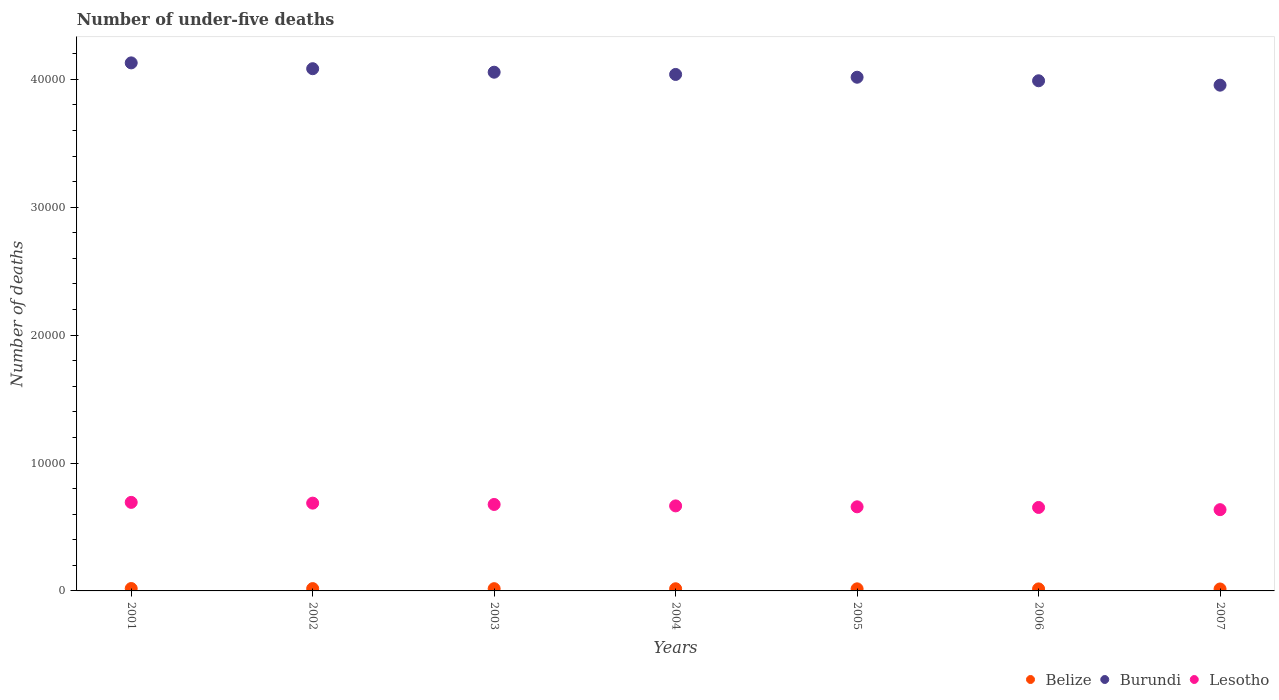How many different coloured dotlines are there?
Give a very brief answer. 3. What is the number of under-five deaths in Belize in 2005?
Provide a succinct answer. 163. Across all years, what is the maximum number of under-five deaths in Burundi?
Provide a short and direct response. 4.13e+04. Across all years, what is the minimum number of under-five deaths in Lesotho?
Make the answer very short. 6352. In which year was the number of under-five deaths in Lesotho maximum?
Your answer should be very brief. 2001. What is the total number of under-five deaths in Lesotho in the graph?
Offer a terse response. 4.66e+04. What is the difference between the number of under-five deaths in Belize in 2004 and that in 2007?
Provide a succinct answer. 17. What is the difference between the number of under-five deaths in Belize in 2002 and the number of under-five deaths in Lesotho in 2007?
Offer a terse response. -6171. What is the average number of under-five deaths in Lesotho per year?
Your answer should be very brief. 6663.29. In the year 2001, what is the difference between the number of under-five deaths in Lesotho and number of under-five deaths in Burundi?
Offer a very short reply. -3.44e+04. In how many years, is the number of under-five deaths in Lesotho greater than 12000?
Offer a terse response. 0. What is the ratio of the number of under-five deaths in Burundi in 2002 to that in 2006?
Provide a succinct answer. 1.02. Is the number of under-five deaths in Belize in 2004 less than that in 2006?
Keep it short and to the point. No. Is the difference between the number of under-five deaths in Lesotho in 2004 and 2007 greater than the difference between the number of under-five deaths in Burundi in 2004 and 2007?
Keep it short and to the point. No. What is the difference between the highest and the second highest number of under-five deaths in Lesotho?
Provide a succinct answer. 59. What is the difference between the highest and the lowest number of under-five deaths in Lesotho?
Your answer should be very brief. 570. In how many years, is the number of under-five deaths in Belize greater than the average number of under-five deaths in Belize taken over all years?
Your response must be concise. 3. Is it the case that in every year, the sum of the number of under-five deaths in Belize and number of under-five deaths in Burundi  is greater than the number of under-five deaths in Lesotho?
Offer a very short reply. Yes. Is the number of under-five deaths in Lesotho strictly greater than the number of under-five deaths in Belize over the years?
Make the answer very short. Yes. Is the number of under-five deaths in Lesotho strictly less than the number of under-five deaths in Belize over the years?
Provide a short and direct response. No. How many dotlines are there?
Offer a very short reply. 3. How many years are there in the graph?
Your answer should be very brief. 7. What is the difference between two consecutive major ticks on the Y-axis?
Offer a very short reply. 10000. Does the graph contain any zero values?
Your response must be concise. No. Where does the legend appear in the graph?
Your response must be concise. Bottom right. How many legend labels are there?
Your answer should be very brief. 3. What is the title of the graph?
Provide a short and direct response. Number of under-five deaths. Does "Curacao" appear as one of the legend labels in the graph?
Your answer should be very brief. No. What is the label or title of the Y-axis?
Offer a very short reply. Number of deaths. What is the Number of deaths of Belize in 2001?
Make the answer very short. 187. What is the Number of deaths in Burundi in 2001?
Your answer should be compact. 4.13e+04. What is the Number of deaths of Lesotho in 2001?
Offer a terse response. 6922. What is the Number of deaths in Belize in 2002?
Offer a terse response. 181. What is the Number of deaths of Burundi in 2002?
Offer a terse response. 4.08e+04. What is the Number of deaths in Lesotho in 2002?
Give a very brief answer. 6863. What is the Number of deaths of Belize in 2003?
Make the answer very short. 175. What is the Number of deaths in Burundi in 2003?
Your answer should be very brief. 4.06e+04. What is the Number of deaths in Lesotho in 2003?
Give a very brief answer. 6759. What is the Number of deaths in Belize in 2004?
Offer a terse response. 169. What is the Number of deaths in Burundi in 2004?
Your response must be concise. 4.04e+04. What is the Number of deaths of Lesotho in 2004?
Provide a succinct answer. 6647. What is the Number of deaths in Belize in 2005?
Make the answer very short. 163. What is the Number of deaths in Burundi in 2005?
Your answer should be very brief. 4.02e+04. What is the Number of deaths of Lesotho in 2005?
Make the answer very short. 6575. What is the Number of deaths in Belize in 2006?
Offer a very short reply. 158. What is the Number of deaths of Burundi in 2006?
Offer a very short reply. 3.99e+04. What is the Number of deaths in Lesotho in 2006?
Offer a very short reply. 6525. What is the Number of deaths in Belize in 2007?
Provide a short and direct response. 152. What is the Number of deaths in Burundi in 2007?
Ensure brevity in your answer.  3.95e+04. What is the Number of deaths in Lesotho in 2007?
Provide a succinct answer. 6352. Across all years, what is the maximum Number of deaths in Belize?
Your response must be concise. 187. Across all years, what is the maximum Number of deaths in Burundi?
Offer a terse response. 4.13e+04. Across all years, what is the maximum Number of deaths in Lesotho?
Ensure brevity in your answer.  6922. Across all years, what is the minimum Number of deaths in Belize?
Offer a terse response. 152. Across all years, what is the minimum Number of deaths in Burundi?
Your answer should be very brief. 3.95e+04. Across all years, what is the minimum Number of deaths in Lesotho?
Provide a succinct answer. 6352. What is the total Number of deaths of Belize in the graph?
Provide a short and direct response. 1185. What is the total Number of deaths in Burundi in the graph?
Make the answer very short. 2.83e+05. What is the total Number of deaths in Lesotho in the graph?
Your answer should be very brief. 4.66e+04. What is the difference between the Number of deaths of Burundi in 2001 and that in 2002?
Offer a terse response. 455. What is the difference between the Number of deaths of Lesotho in 2001 and that in 2002?
Make the answer very short. 59. What is the difference between the Number of deaths in Belize in 2001 and that in 2003?
Keep it short and to the point. 12. What is the difference between the Number of deaths of Burundi in 2001 and that in 2003?
Your answer should be very brief. 729. What is the difference between the Number of deaths in Lesotho in 2001 and that in 2003?
Give a very brief answer. 163. What is the difference between the Number of deaths of Belize in 2001 and that in 2004?
Offer a terse response. 18. What is the difference between the Number of deaths in Burundi in 2001 and that in 2004?
Provide a succinct answer. 904. What is the difference between the Number of deaths in Lesotho in 2001 and that in 2004?
Ensure brevity in your answer.  275. What is the difference between the Number of deaths in Burundi in 2001 and that in 2005?
Your response must be concise. 1122. What is the difference between the Number of deaths of Lesotho in 2001 and that in 2005?
Offer a very short reply. 347. What is the difference between the Number of deaths of Burundi in 2001 and that in 2006?
Keep it short and to the point. 1399. What is the difference between the Number of deaths in Lesotho in 2001 and that in 2006?
Make the answer very short. 397. What is the difference between the Number of deaths in Burundi in 2001 and that in 2007?
Your answer should be compact. 1742. What is the difference between the Number of deaths in Lesotho in 2001 and that in 2007?
Provide a succinct answer. 570. What is the difference between the Number of deaths of Belize in 2002 and that in 2003?
Offer a terse response. 6. What is the difference between the Number of deaths of Burundi in 2002 and that in 2003?
Provide a short and direct response. 274. What is the difference between the Number of deaths in Lesotho in 2002 and that in 2003?
Provide a succinct answer. 104. What is the difference between the Number of deaths in Burundi in 2002 and that in 2004?
Offer a very short reply. 449. What is the difference between the Number of deaths in Lesotho in 2002 and that in 2004?
Your response must be concise. 216. What is the difference between the Number of deaths in Belize in 2002 and that in 2005?
Keep it short and to the point. 18. What is the difference between the Number of deaths in Burundi in 2002 and that in 2005?
Your response must be concise. 667. What is the difference between the Number of deaths of Lesotho in 2002 and that in 2005?
Offer a very short reply. 288. What is the difference between the Number of deaths of Belize in 2002 and that in 2006?
Keep it short and to the point. 23. What is the difference between the Number of deaths in Burundi in 2002 and that in 2006?
Your answer should be very brief. 944. What is the difference between the Number of deaths of Lesotho in 2002 and that in 2006?
Provide a succinct answer. 338. What is the difference between the Number of deaths of Belize in 2002 and that in 2007?
Your response must be concise. 29. What is the difference between the Number of deaths in Burundi in 2002 and that in 2007?
Ensure brevity in your answer.  1287. What is the difference between the Number of deaths in Lesotho in 2002 and that in 2007?
Give a very brief answer. 511. What is the difference between the Number of deaths in Burundi in 2003 and that in 2004?
Your answer should be very brief. 175. What is the difference between the Number of deaths of Lesotho in 2003 and that in 2004?
Provide a succinct answer. 112. What is the difference between the Number of deaths in Belize in 2003 and that in 2005?
Your answer should be compact. 12. What is the difference between the Number of deaths in Burundi in 2003 and that in 2005?
Provide a succinct answer. 393. What is the difference between the Number of deaths in Lesotho in 2003 and that in 2005?
Your response must be concise. 184. What is the difference between the Number of deaths of Belize in 2003 and that in 2006?
Offer a terse response. 17. What is the difference between the Number of deaths of Burundi in 2003 and that in 2006?
Offer a terse response. 670. What is the difference between the Number of deaths in Lesotho in 2003 and that in 2006?
Give a very brief answer. 234. What is the difference between the Number of deaths in Burundi in 2003 and that in 2007?
Your response must be concise. 1013. What is the difference between the Number of deaths in Lesotho in 2003 and that in 2007?
Keep it short and to the point. 407. What is the difference between the Number of deaths of Belize in 2004 and that in 2005?
Offer a terse response. 6. What is the difference between the Number of deaths of Burundi in 2004 and that in 2005?
Provide a short and direct response. 218. What is the difference between the Number of deaths of Burundi in 2004 and that in 2006?
Your answer should be very brief. 495. What is the difference between the Number of deaths in Lesotho in 2004 and that in 2006?
Offer a terse response. 122. What is the difference between the Number of deaths of Belize in 2004 and that in 2007?
Keep it short and to the point. 17. What is the difference between the Number of deaths in Burundi in 2004 and that in 2007?
Offer a terse response. 838. What is the difference between the Number of deaths of Lesotho in 2004 and that in 2007?
Give a very brief answer. 295. What is the difference between the Number of deaths of Burundi in 2005 and that in 2006?
Make the answer very short. 277. What is the difference between the Number of deaths in Belize in 2005 and that in 2007?
Provide a succinct answer. 11. What is the difference between the Number of deaths of Burundi in 2005 and that in 2007?
Your answer should be compact. 620. What is the difference between the Number of deaths of Lesotho in 2005 and that in 2007?
Your response must be concise. 223. What is the difference between the Number of deaths of Burundi in 2006 and that in 2007?
Your answer should be compact. 343. What is the difference between the Number of deaths of Lesotho in 2006 and that in 2007?
Keep it short and to the point. 173. What is the difference between the Number of deaths of Belize in 2001 and the Number of deaths of Burundi in 2002?
Your response must be concise. -4.06e+04. What is the difference between the Number of deaths in Belize in 2001 and the Number of deaths in Lesotho in 2002?
Ensure brevity in your answer.  -6676. What is the difference between the Number of deaths of Burundi in 2001 and the Number of deaths of Lesotho in 2002?
Ensure brevity in your answer.  3.44e+04. What is the difference between the Number of deaths of Belize in 2001 and the Number of deaths of Burundi in 2003?
Offer a very short reply. -4.04e+04. What is the difference between the Number of deaths of Belize in 2001 and the Number of deaths of Lesotho in 2003?
Give a very brief answer. -6572. What is the difference between the Number of deaths of Burundi in 2001 and the Number of deaths of Lesotho in 2003?
Your response must be concise. 3.45e+04. What is the difference between the Number of deaths in Belize in 2001 and the Number of deaths in Burundi in 2004?
Provide a succinct answer. -4.02e+04. What is the difference between the Number of deaths in Belize in 2001 and the Number of deaths in Lesotho in 2004?
Offer a terse response. -6460. What is the difference between the Number of deaths in Burundi in 2001 and the Number of deaths in Lesotho in 2004?
Provide a succinct answer. 3.46e+04. What is the difference between the Number of deaths in Belize in 2001 and the Number of deaths in Burundi in 2005?
Your response must be concise. -4.00e+04. What is the difference between the Number of deaths in Belize in 2001 and the Number of deaths in Lesotho in 2005?
Provide a succinct answer. -6388. What is the difference between the Number of deaths in Burundi in 2001 and the Number of deaths in Lesotho in 2005?
Offer a terse response. 3.47e+04. What is the difference between the Number of deaths of Belize in 2001 and the Number of deaths of Burundi in 2006?
Keep it short and to the point. -3.97e+04. What is the difference between the Number of deaths of Belize in 2001 and the Number of deaths of Lesotho in 2006?
Your answer should be compact. -6338. What is the difference between the Number of deaths of Burundi in 2001 and the Number of deaths of Lesotho in 2006?
Make the answer very short. 3.48e+04. What is the difference between the Number of deaths of Belize in 2001 and the Number of deaths of Burundi in 2007?
Keep it short and to the point. -3.94e+04. What is the difference between the Number of deaths of Belize in 2001 and the Number of deaths of Lesotho in 2007?
Ensure brevity in your answer.  -6165. What is the difference between the Number of deaths of Burundi in 2001 and the Number of deaths of Lesotho in 2007?
Keep it short and to the point. 3.49e+04. What is the difference between the Number of deaths in Belize in 2002 and the Number of deaths in Burundi in 2003?
Your answer should be compact. -4.04e+04. What is the difference between the Number of deaths in Belize in 2002 and the Number of deaths in Lesotho in 2003?
Ensure brevity in your answer.  -6578. What is the difference between the Number of deaths of Burundi in 2002 and the Number of deaths of Lesotho in 2003?
Your answer should be compact. 3.41e+04. What is the difference between the Number of deaths of Belize in 2002 and the Number of deaths of Burundi in 2004?
Provide a succinct answer. -4.02e+04. What is the difference between the Number of deaths in Belize in 2002 and the Number of deaths in Lesotho in 2004?
Your response must be concise. -6466. What is the difference between the Number of deaths in Burundi in 2002 and the Number of deaths in Lesotho in 2004?
Keep it short and to the point. 3.42e+04. What is the difference between the Number of deaths in Belize in 2002 and the Number of deaths in Burundi in 2005?
Your answer should be very brief. -4.00e+04. What is the difference between the Number of deaths of Belize in 2002 and the Number of deaths of Lesotho in 2005?
Keep it short and to the point. -6394. What is the difference between the Number of deaths in Burundi in 2002 and the Number of deaths in Lesotho in 2005?
Your answer should be compact. 3.42e+04. What is the difference between the Number of deaths in Belize in 2002 and the Number of deaths in Burundi in 2006?
Offer a very short reply. -3.97e+04. What is the difference between the Number of deaths in Belize in 2002 and the Number of deaths in Lesotho in 2006?
Your response must be concise. -6344. What is the difference between the Number of deaths of Burundi in 2002 and the Number of deaths of Lesotho in 2006?
Keep it short and to the point. 3.43e+04. What is the difference between the Number of deaths of Belize in 2002 and the Number of deaths of Burundi in 2007?
Make the answer very short. -3.94e+04. What is the difference between the Number of deaths of Belize in 2002 and the Number of deaths of Lesotho in 2007?
Keep it short and to the point. -6171. What is the difference between the Number of deaths in Burundi in 2002 and the Number of deaths in Lesotho in 2007?
Keep it short and to the point. 3.45e+04. What is the difference between the Number of deaths in Belize in 2003 and the Number of deaths in Burundi in 2004?
Offer a very short reply. -4.02e+04. What is the difference between the Number of deaths of Belize in 2003 and the Number of deaths of Lesotho in 2004?
Provide a succinct answer. -6472. What is the difference between the Number of deaths in Burundi in 2003 and the Number of deaths in Lesotho in 2004?
Offer a very short reply. 3.39e+04. What is the difference between the Number of deaths in Belize in 2003 and the Number of deaths in Burundi in 2005?
Keep it short and to the point. -4.00e+04. What is the difference between the Number of deaths in Belize in 2003 and the Number of deaths in Lesotho in 2005?
Your response must be concise. -6400. What is the difference between the Number of deaths of Burundi in 2003 and the Number of deaths of Lesotho in 2005?
Your response must be concise. 3.40e+04. What is the difference between the Number of deaths of Belize in 2003 and the Number of deaths of Burundi in 2006?
Your response must be concise. -3.97e+04. What is the difference between the Number of deaths of Belize in 2003 and the Number of deaths of Lesotho in 2006?
Offer a very short reply. -6350. What is the difference between the Number of deaths of Burundi in 2003 and the Number of deaths of Lesotho in 2006?
Provide a short and direct response. 3.40e+04. What is the difference between the Number of deaths in Belize in 2003 and the Number of deaths in Burundi in 2007?
Give a very brief answer. -3.94e+04. What is the difference between the Number of deaths in Belize in 2003 and the Number of deaths in Lesotho in 2007?
Your answer should be compact. -6177. What is the difference between the Number of deaths of Burundi in 2003 and the Number of deaths of Lesotho in 2007?
Make the answer very short. 3.42e+04. What is the difference between the Number of deaths of Belize in 2004 and the Number of deaths of Burundi in 2005?
Provide a short and direct response. -4.00e+04. What is the difference between the Number of deaths of Belize in 2004 and the Number of deaths of Lesotho in 2005?
Provide a short and direct response. -6406. What is the difference between the Number of deaths of Burundi in 2004 and the Number of deaths of Lesotho in 2005?
Your response must be concise. 3.38e+04. What is the difference between the Number of deaths of Belize in 2004 and the Number of deaths of Burundi in 2006?
Your response must be concise. -3.97e+04. What is the difference between the Number of deaths of Belize in 2004 and the Number of deaths of Lesotho in 2006?
Offer a terse response. -6356. What is the difference between the Number of deaths in Burundi in 2004 and the Number of deaths in Lesotho in 2006?
Offer a very short reply. 3.39e+04. What is the difference between the Number of deaths of Belize in 2004 and the Number of deaths of Burundi in 2007?
Give a very brief answer. -3.94e+04. What is the difference between the Number of deaths in Belize in 2004 and the Number of deaths in Lesotho in 2007?
Your answer should be very brief. -6183. What is the difference between the Number of deaths of Burundi in 2004 and the Number of deaths of Lesotho in 2007?
Ensure brevity in your answer.  3.40e+04. What is the difference between the Number of deaths in Belize in 2005 and the Number of deaths in Burundi in 2006?
Provide a succinct answer. -3.97e+04. What is the difference between the Number of deaths in Belize in 2005 and the Number of deaths in Lesotho in 2006?
Provide a short and direct response. -6362. What is the difference between the Number of deaths of Burundi in 2005 and the Number of deaths of Lesotho in 2006?
Make the answer very short. 3.36e+04. What is the difference between the Number of deaths of Belize in 2005 and the Number of deaths of Burundi in 2007?
Offer a very short reply. -3.94e+04. What is the difference between the Number of deaths of Belize in 2005 and the Number of deaths of Lesotho in 2007?
Your answer should be compact. -6189. What is the difference between the Number of deaths in Burundi in 2005 and the Number of deaths in Lesotho in 2007?
Provide a succinct answer. 3.38e+04. What is the difference between the Number of deaths in Belize in 2006 and the Number of deaths in Burundi in 2007?
Provide a succinct answer. -3.94e+04. What is the difference between the Number of deaths in Belize in 2006 and the Number of deaths in Lesotho in 2007?
Keep it short and to the point. -6194. What is the difference between the Number of deaths of Burundi in 2006 and the Number of deaths of Lesotho in 2007?
Your response must be concise. 3.35e+04. What is the average Number of deaths in Belize per year?
Offer a very short reply. 169.29. What is the average Number of deaths in Burundi per year?
Your response must be concise. 4.04e+04. What is the average Number of deaths of Lesotho per year?
Give a very brief answer. 6663.29. In the year 2001, what is the difference between the Number of deaths of Belize and Number of deaths of Burundi?
Your answer should be compact. -4.11e+04. In the year 2001, what is the difference between the Number of deaths in Belize and Number of deaths in Lesotho?
Keep it short and to the point. -6735. In the year 2001, what is the difference between the Number of deaths in Burundi and Number of deaths in Lesotho?
Offer a very short reply. 3.44e+04. In the year 2002, what is the difference between the Number of deaths in Belize and Number of deaths in Burundi?
Provide a succinct answer. -4.06e+04. In the year 2002, what is the difference between the Number of deaths in Belize and Number of deaths in Lesotho?
Give a very brief answer. -6682. In the year 2002, what is the difference between the Number of deaths in Burundi and Number of deaths in Lesotho?
Your response must be concise. 3.40e+04. In the year 2003, what is the difference between the Number of deaths of Belize and Number of deaths of Burundi?
Give a very brief answer. -4.04e+04. In the year 2003, what is the difference between the Number of deaths in Belize and Number of deaths in Lesotho?
Provide a succinct answer. -6584. In the year 2003, what is the difference between the Number of deaths of Burundi and Number of deaths of Lesotho?
Make the answer very short. 3.38e+04. In the year 2004, what is the difference between the Number of deaths of Belize and Number of deaths of Burundi?
Your answer should be very brief. -4.02e+04. In the year 2004, what is the difference between the Number of deaths in Belize and Number of deaths in Lesotho?
Your answer should be very brief. -6478. In the year 2004, what is the difference between the Number of deaths of Burundi and Number of deaths of Lesotho?
Your answer should be very brief. 3.37e+04. In the year 2005, what is the difference between the Number of deaths in Belize and Number of deaths in Burundi?
Your response must be concise. -4.00e+04. In the year 2005, what is the difference between the Number of deaths of Belize and Number of deaths of Lesotho?
Make the answer very short. -6412. In the year 2005, what is the difference between the Number of deaths of Burundi and Number of deaths of Lesotho?
Provide a short and direct response. 3.36e+04. In the year 2006, what is the difference between the Number of deaths in Belize and Number of deaths in Burundi?
Ensure brevity in your answer.  -3.97e+04. In the year 2006, what is the difference between the Number of deaths of Belize and Number of deaths of Lesotho?
Your response must be concise. -6367. In the year 2006, what is the difference between the Number of deaths in Burundi and Number of deaths in Lesotho?
Your answer should be very brief. 3.34e+04. In the year 2007, what is the difference between the Number of deaths in Belize and Number of deaths in Burundi?
Keep it short and to the point. -3.94e+04. In the year 2007, what is the difference between the Number of deaths in Belize and Number of deaths in Lesotho?
Your answer should be compact. -6200. In the year 2007, what is the difference between the Number of deaths in Burundi and Number of deaths in Lesotho?
Give a very brief answer. 3.32e+04. What is the ratio of the Number of deaths of Belize in 2001 to that in 2002?
Your response must be concise. 1.03. What is the ratio of the Number of deaths in Burundi in 2001 to that in 2002?
Your answer should be very brief. 1.01. What is the ratio of the Number of deaths in Lesotho in 2001 to that in 2002?
Provide a succinct answer. 1.01. What is the ratio of the Number of deaths of Belize in 2001 to that in 2003?
Provide a short and direct response. 1.07. What is the ratio of the Number of deaths in Lesotho in 2001 to that in 2003?
Provide a short and direct response. 1.02. What is the ratio of the Number of deaths of Belize in 2001 to that in 2004?
Your answer should be compact. 1.11. What is the ratio of the Number of deaths of Burundi in 2001 to that in 2004?
Offer a very short reply. 1.02. What is the ratio of the Number of deaths in Lesotho in 2001 to that in 2004?
Your answer should be compact. 1.04. What is the ratio of the Number of deaths in Belize in 2001 to that in 2005?
Your answer should be compact. 1.15. What is the ratio of the Number of deaths in Burundi in 2001 to that in 2005?
Your answer should be very brief. 1.03. What is the ratio of the Number of deaths in Lesotho in 2001 to that in 2005?
Your response must be concise. 1.05. What is the ratio of the Number of deaths in Belize in 2001 to that in 2006?
Offer a very short reply. 1.18. What is the ratio of the Number of deaths of Burundi in 2001 to that in 2006?
Ensure brevity in your answer.  1.04. What is the ratio of the Number of deaths in Lesotho in 2001 to that in 2006?
Offer a very short reply. 1.06. What is the ratio of the Number of deaths in Belize in 2001 to that in 2007?
Provide a succinct answer. 1.23. What is the ratio of the Number of deaths in Burundi in 2001 to that in 2007?
Give a very brief answer. 1.04. What is the ratio of the Number of deaths in Lesotho in 2001 to that in 2007?
Offer a terse response. 1.09. What is the ratio of the Number of deaths of Belize in 2002 to that in 2003?
Offer a terse response. 1.03. What is the ratio of the Number of deaths in Burundi in 2002 to that in 2003?
Your answer should be very brief. 1.01. What is the ratio of the Number of deaths of Lesotho in 2002 to that in 2003?
Provide a succinct answer. 1.02. What is the ratio of the Number of deaths in Belize in 2002 to that in 2004?
Offer a terse response. 1.07. What is the ratio of the Number of deaths of Burundi in 2002 to that in 2004?
Give a very brief answer. 1.01. What is the ratio of the Number of deaths in Lesotho in 2002 to that in 2004?
Your response must be concise. 1.03. What is the ratio of the Number of deaths in Belize in 2002 to that in 2005?
Ensure brevity in your answer.  1.11. What is the ratio of the Number of deaths in Burundi in 2002 to that in 2005?
Provide a short and direct response. 1.02. What is the ratio of the Number of deaths in Lesotho in 2002 to that in 2005?
Your answer should be very brief. 1.04. What is the ratio of the Number of deaths in Belize in 2002 to that in 2006?
Your answer should be compact. 1.15. What is the ratio of the Number of deaths in Burundi in 2002 to that in 2006?
Ensure brevity in your answer.  1.02. What is the ratio of the Number of deaths of Lesotho in 2002 to that in 2006?
Make the answer very short. 1.05. What is the ratio of the Number of deaths in Belize in 2002 to that in 2007?
Make the answer very short. 1.19. What is the ratio of the Number of deaths in Burundi in 2002 to that in 2007?
Make the answer very short. 1.03. What is the ratio of the Number of deaths in Lesotho in 2002 to that in 2007?
Give a very brief answer. 1.08. What is the ratio of the Number of deaths in Belize in 2003 to that in 2004?
Your answer should be very brief. 1.04. What is the ratio of the Number of deaths in Burundi in 2003 to that in 2004?
Give a very brief answer. 1. What is the ratio of the Number of deaths in Lesotho in 2003 to that in 2004?
Offer a very short reply. 1.02. What is the ratio of the Number of deaths in Belize in 2003 to that in 2005?
Offer a very short reply. 1.07. What is the ratio of the Number of deaths in Burundi in 2003 to that in 2005?
Ensure brevity in your answer.  1.01. What is the ratio of the Number of deaths in Lesotho in 2003 to that in 2005?
Keep it short and to the point. 1.03. What is the ratio of the Number of deaths of Belize in 2003 to that in 2006?
Your answer should be compact. 1.11. What is the ratio of the Number of deaths in Burundi in 2003 to that in 2006?
Ensure brevity in your answer.  1.02. What is the ratio of the Number of deaths in Lesotho in 2003 to that in 2006?
Make the answer very short. 1.04. What is the ratio of the Number of deaths in Belize in 2003 to that in 2007?
Make the answer very short. 1.15. What is the ratio of the Number of deaths in Burundi in 2003 to that in 2007?
Offer a terse response. 1.03. What is the ratio of the Number of deaths of Lesotho in 2003 to that in 2007?
Your answer should be compact. 1.06. What is the ratio of the Number of deaths in Belize in 2004 to that in 2005?
Offer a very short reply. 1.04. What is the ratio of the Number of deaths of Burundi in 2004 to that in 2005?
Make the answer very short. 1.01. What is the ratio of the Number of deaths of Belize in 2004 to that in 2006?
Your response must be concise. 1.07. What is the ratio of the Number of deaths of Burundi in 2004 to that in 2006?
Make the answer very short. 1.01. What is the ratio of the Number of deaths in Lesotho in 2004 to that in 2006?
Provide a short and direct response. 1.02. What is the ratio of the Number of deaths in Belize in 2004 to that in 2007?
Offer a terse response. 1.11. What is the ratio of the Number of deaths in Burundi in 2004 to that in 2007?
Your response must be concise. 1.02. What is the ratio of the Number of deaths of Lesotho in 2004 to that in 2007?
Keep it short and to the point. 1.05. What is the ratio of the Number of deaths in Belize in 2005 to that in 2006?
Keep it short and to the point. 1.03. What is the ratio of the Number of deaths of Lesotho in 2005 to that in 2006?
Ensure brevity in your answer.  1.01. What is the ratio of the Number of deaths of Belize in 2005 to that in 2007?
Keep it short and to the point. 1.07. What is the ratio of the Number of deaths of Burundi in 2005 to that in 2007?
Your response must be concise. 1.02. What is the ratio of the Number of deaths in Lesotho in 2005 to that in 2007?
Keep it short and to the point. 1.04. What is the ratio of the Number of deaths in Belize in 2006 to that in 2007?
Provide a succinct answer. 1.04. What is the ratio of the Number of deaths in Burundi in 2006 to that in 2007?
Offer a very short reply. 1.01. What is the ratio of the Number of deaths in Lesotho in 2006 to that in 2007?
Your response must be concise. 1.03. What is the difference between the highest and the second highest Number of deaths of Burundi?
Ensure brevity in your answer.  455. What is the difference between the highest and the lowest Number of deaths of Burundi?
Your answer should be very brief. 1742. What is the difference between the highest and the lowest Number of deaths in Lesotho?
Your answer should be compact. 570. 